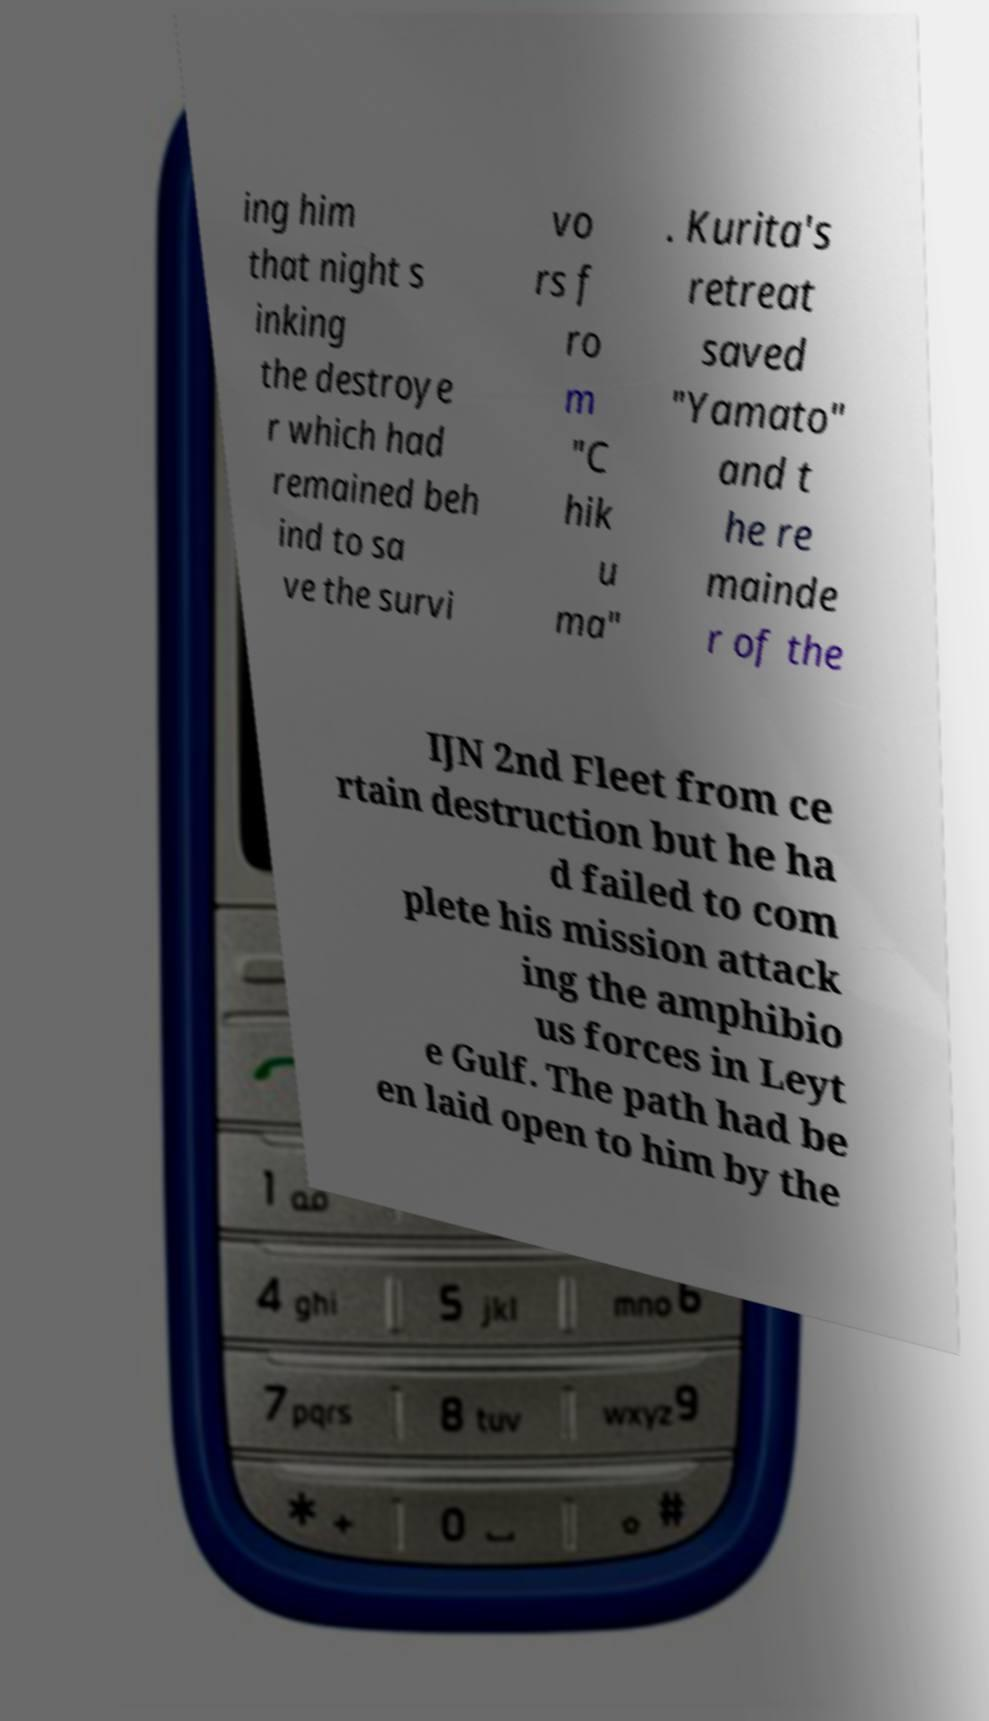Can you accurately transcribe the text from the provided image for me? ing him that night s inking the destroye r which had remained beh ind to sa ve the survi vo rs f ro m "C hik u ma" . Kurita's retreat saved "Yamato" and t he re mainde r of the IJN 2nd Fleet from ce rtain destruction but he ha d failed to com plete his mission attack ing the amphibio us forces in Leyt e Gulf. The path had be en laid open to him by the 